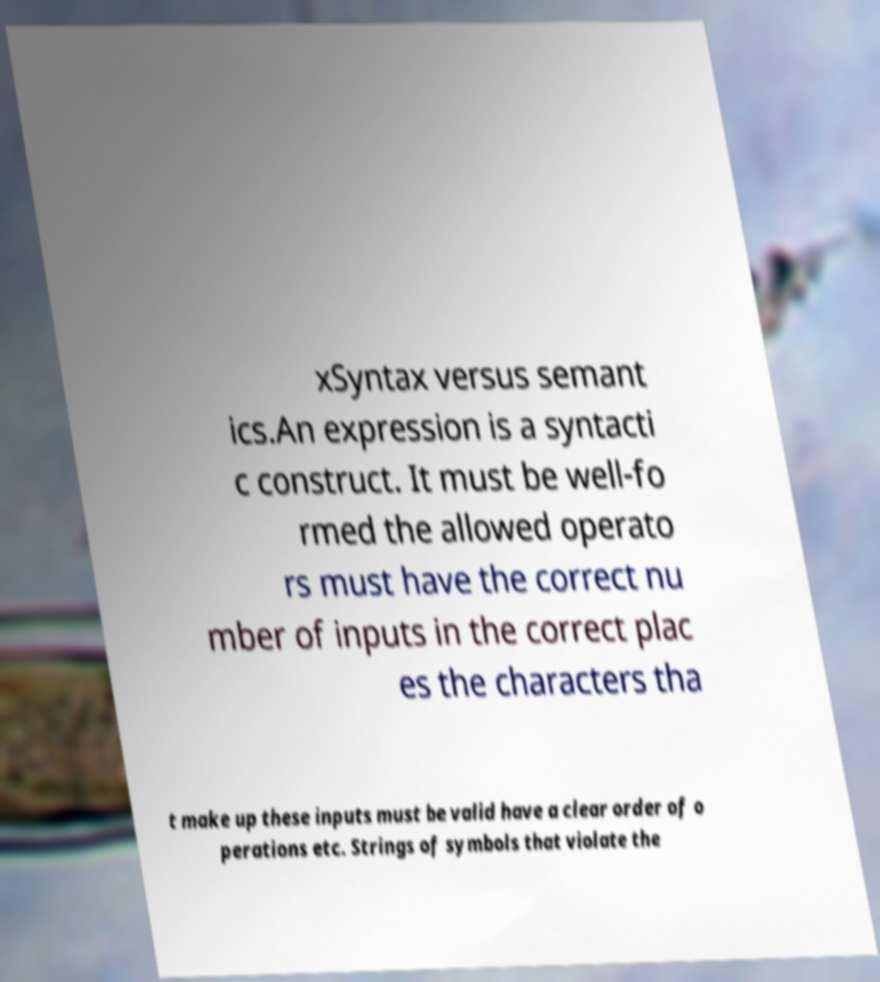Could you extract and type out the text from this image? xSyntax versus semant ics.An expression is a syntacti c construct. It must be well-fo rmed the allowed operato rs must have the correct nu mber of inputs in the correct plac es the characters tha t make up these inputs must be valid have a clear order of o perations etc. Strings of symbols that violate the 